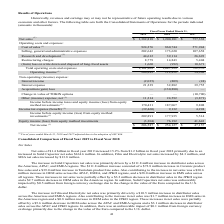According to Kemet Corporation's financial document, Why were calculations for Fiscal years ended March 31, 2018 and 2017 adjusted? due to the adoption of ASC 606.. The document states: "iscal years ended March 31, 2018 and 2017 adjusted due to the adoption of ASC 606...." Also, Which years does the table provide information for the company's Consolidated Statements of Operations? The document contains multiple relevant values: 2019, 2018, 2017. From the document: "2019 2018 2017 2019 2018 2017 2019 2018 2017..." Also, What were the net sales in 2019? According to the financial document, 1,382,818 (in thousands). The relevant text states: "Net sales (1) $ 1,382,818 $ 1,200,181 $ 757,338..." Also, How many years did net other (income) expense exceed $10,000 thousand? Counting the relevant items in the document: 2019, 2018, I find 2 instances. The key data points involved are: 2018, 2019. Also, can you calculate: What was the change in Interest expense between 2017 and 2018? Based on the calculation: 32,882-39,755, the result is -6873 (in thousands). This is based on the information: "Interest expense 21,239 32,882 39,755 Interest expense 21,239 32,882 39,755..." The key data points involved are: 32,882, 39,755. Also, can you calculate: What was the percentage change in the net income between 2018 and 2019? To answer this question, I need to perform calculations using the financial data. The calculation is: (206,587-254,127)/254,127, which equals -18.71 (percentage). This is based on the information: "Net income (1) $ 206,587 $ 254,127 $ 47,157 Net income (1) $ 206,587 $ 254,127 $ 47,157..." The key data points involved are: 206,587, 254,127. 